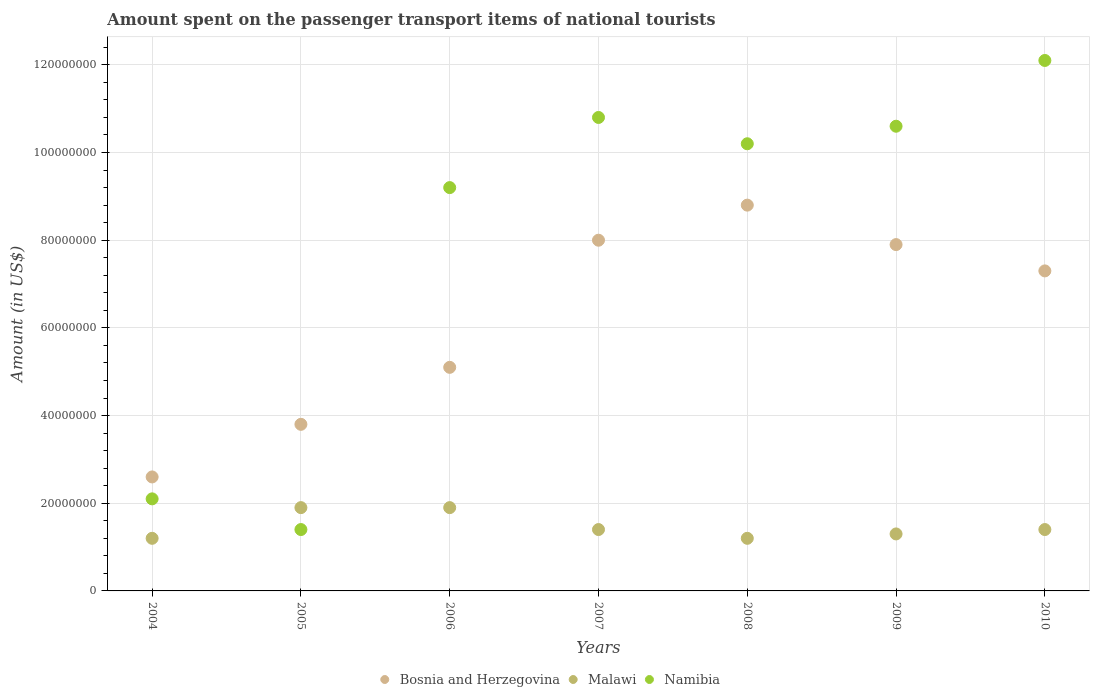How many different coloured dotlines are there?
Offer a very short reply. 3. What is the amount spent on the passenger transport items of national tourists in Bosnia and Herzegovina in 2006?
Give a very brief answer. 5.10e+07. Across all years, what is the maximum amount spent on the passenger transport items of national tourists in Namibia?
Give a very brief answer. 1.21e+08. Across all years, what is the minimum amount spent on the passenger transport items of national tourists in Namibia?
Your answer should be very brief. 1.40e+07. In which year was the amount spent on the passenger transport items of national tourists in Bosnia and Herzegovina maximum?
Give a very brief answer. 2008. In which year was the amount spent on the passenger transport items of national tourists in Bosnia and Herzegovina minimum?
Provide a succinct answer. 2004. What is the total amount spent on the passenger transport items of national tourists in Namibia in the graph?
Give a very brief answer. 5.64e+08. What is the difference between the amount spent on the passenger transport items of national tourists in Malawi in 2008 and that in 2009?
Your answer should be very brief. -1.00e+06. What is the difference between the amount spent on the passenger transport items of national tourists in Malawi in 2004 and the amount spent on the passenger transport items of national tourists in Bosnia and Herzegovina in 2007?
Keep it short and to the point. -6.80e+07. What is the average amount spent on the passenger transport items of national tourists in Namibia per year?
Your response must be concise. 8.06e+07. In the year 2005, what is the difference between the amount spent on the passenger transport items of national tourists in Bosnia and Herzegovina and amount spent on the passenger transport items of national tourists in Malawi?
Your answer should be compact. 1.90e+07. In how many years, is the amount spent on the passenger transport items of national tourists in Malawi greater than 60000000 US$?
Your answer should be very brief. 0. What is the ratio of the amount spent on the passenger transport items of national tourists in Bosnia and Herzegovina in 2004 to that in 2005?
Provide a short and direct response. 0.68. What is the difference between the highest and the second highest amount spent on the passenger transport items of national tourists in Malawi?
Ensure brevity in your answer.  0. What is the difference between the highest and the lowest amount spent on the passenger transport items of national tourists in Bosnia and Herzegovina?
Keep it short and to the point. 6.20e+07. In how many years, is the amount spent on the passenger transport items of national tourists in Namibia greater than the average amount spent on the passenger transport items of national tourists in Namibia taken over all years?
Offer a very short reply. 5. Does the amount spent on the passenger transport items of national tourists in Malawi monotonically increase over the years?
Offer a very short reply. No. Is the amount spent on the passenger transport items of national tourists in Namibia strictly greater than the amount spent on the passenger transport items of national tourists in Bosnia and Herzegovina over the years?
Provide a short and direct response. No. Is the amount spent on the passenger transport items of national tourists in Bosnia and Herzegovina strictly less than the amount spent on the passenger transport items of national tourists in Namibia over the years?
Keep it short and to the point. No. How many years are there in the graph?
Provide a succinct answer. 7. What is the difference between two consecutive major ticks on the Y-axis?
Offer a terse response. 2.00e+07. Are the values on the major ticks of Y-axis written in scientific E-notation?
Keep it short and to the point. No. Does the graph contain any zero values?
Offer a terse response. No. Where does the legend appear in the graph?
Your response must be concise. Bottom center. How many legend labels are there?
Your answer should be compact. 3. What is the title of the graph?
Give a very brief answer. Amount spent on the passenger transport items of national tourists. What is the Amount (in US$) in Bosnia and Herzegovina in 2004?
Your response must be concise. 2.60e+07. What is the Amount (in US$) in Namibia in 2004?
Make the answer very short. 2.10e+07. What is the Amount (in US$) in Bosnia and Herzegovina in 2005?
Keep it short and to the point. 3.80e+07. What is the Amount (in US$) in Malawi in 2005?
Your answer should be compact. 1.90e+07. What is the Amount (in US$) in Namibia in 2005?
Your answer should be compact. 1.40e+07. What is the Amount (in US$) in Bosnia and Herzegovina in 2006?
Ensure brevity in your answer.  5.10e+07. What is the Amount (in US$) in Malawi in 2006?
Ensure brevity in your answer.  1.90e+07. What is the Amount (in US$) of Namibia in 2006?
Provide a succinct answer. 9.20e+07. What is the Amount (in US$) of Bosnia and Herzegovina in 2007?
Ensure brevity in your answer.  8.00e+07. What is the Amount (in US$) of Malawi in 2007?
Make the answer very short. 1.40e+07. What is the Amount (in US$) in Namibia in 2007?
Provide a short and direct response. 1.08e+08. What is the Amount (in US$) in Bosnia and Herzegovina in 2008?
Ensure brevity in your answer.  8.80e+07. What is the Amount (in US$) of Namibia in 2008?
Your answer should be very brief. 1.02e+08. What is the Amount (in US$) of Bosnia and Herzegovina in 2009?
Give a very brief answer. 7.90e+07. What is the Amount (in US$) in Malawi in 2009?
Ensure brevity in your answer.  1.30e+07. What is the Amount (in US$) in Namibia in 2009?
Ensure brevity in your answer.  1.06e+08. What is the Amount (in US$) of Bosnia and Herzegovina in 2010?
Provide a short and direct response. 7.30e+07. What is the Amount (in US$) of Malawi in 2010?
Keep it short and to the point. 1.40e+07. What is the Amount (in US$) in Namibia in 2010?
Your answer should be very brief. 1.21e+08. Across all years, what is the maximum Amount (in US$) in Bosnia and Herzegovina?
Keep it short and to the point. 8.80e+07. Across all years, what is the maximum Amount (in US$) of Malawi?
Keep it short and to the point. 1.90e+07. Across all years, what is the maximum Amount (in US$) in Namibia?
Give a very brief answer. 1.21e+08. Across all years, what is the minimum Amount (in US$) of Bosnia and Herzegovina?
Your response must be concise. 2.60e+07. Across all years, what is the minimum Amount (in US$) in Namibia?
Ensure brevity in your answer.  1.40e+07. What is the total Amount (in US$) of Bosnia and Herzegovina in the graph?
Your answer should be compact. 4.35e+08. What is the total Amount (in US$) in Malawi in the graph?
Give a very brief answer. 1.03e+08. What is the total Amount (in US$) in Namibia in the graph?
Make the answer very short. 5.64e+08. What is the difference between the Amount (in US$) in Bosnia and Herzegovina in 2004 and that in 2005?
Give a very brief answer. -1.20e+07. What is the difference between the Amount (in US$) in Malawi in 2004 and that in 2005?
Keep it short and to the point. -7.00e+06. What is the difference between the Amount (in US$) in Bosnia and Herzegovina in 2004 and that in 2006?
Give a very brief answer. -2.50e+07. What is the difference between the Amount (in US$) of Malawi in 2004 and that in 2006?
Provide a short and direct response. -7.00e+06. What is the difference between the Amount (in US$) of Namibia in 2004 and that in 2006?
Your answer should be very brief. -7.10e+07. What is the difference between the Amount (in US$) in Bosnia and Herzegovina in 2004 and that in 2007?
Provide a succinct answer. -5.40e+07. What is the difference between the Amount (in US$) of Malawi in 2004 and that in 2007?
Make the answer very short. -2.00e+06. What is the difference between the Amount (in US$) in Namibia in 2004 and that in 2007?
Offer a very short reply. -8.70e+07. What is the difference between the Amount (in US$) in Bosnia and Herzegovina in 2004 and that in 2008?
Offer a terse response. -6.20e+07. What is the difference between the Amount (in US$) in Malawi in 2004 and that in 2008?
Offer a very short reply. 0. What is the difference between the Amount (in US$) of Namibia in 2004 and that in 2008?
Provide a short and direct response. -8.10e+07. What is the difference between the Amount (in US$) of Bosnia and Herzegovina in 2004 and that in 2009?
Make the answer very short. -5.30e+07. What is the difference between the Amount (in US$) in Malawi in 2004 and that in 2009?
Offer a terse response. -1.00e+06. What is the difference between the Amount (in US$) in Namibia in 2004 and that in 2009?
Ensure brevity in your answer.  -8.50e+07. What is the difference between the Amount (in US$) in Bosnia and Herzegovina in 2004 and that in 2010?
Your answer should be compact. -4.70e+07. What is the difference between the Amount (in US$) of Namibia in 2004 and that in 2010?
Offer a terse response. -1.00e+08. What is the difference between the Amount (in US$) in Bosnia and Herzegovina in 2005 and that in 2006?
Provide a succinct answer. -1.30e+07. What is the difference between the Amount (in US$) in Malawi in 2005 and that in 2006?
Make the answer very short. 0. What is the difference between the Amount (in US$) of Namibia in 2005 and that in 2006?
Offer a very short reply. -7.80e+07. What is the difference between the Amount (in US$) in Bosnia and Herzegovina in 2005 and that in 2007?
Keep it short and to the point. -4.20e+07. What is the difference between the Amount (in US$) of Malawi in 2005 and that in 2007?
Give a very brief answer. 5.00e+06. What is the difference between the Amount (in US$) in Namibia in 2005 and that in 2007?
Keep it short and to the point. -9.40e+07. What is the difference between the Amount (in US$) of Bosnia and Herzegovina in 2005 and that in 2008?
Your answer should be compact. -5.00e+07. What is the difference between the Amount (in US$) in Namibia in 2005 and that in 2008?
Your answer should be very brief. -8.80e+07. What is the difference between the Amount (in US$) of Bosnia and Herzegovina in 2005 and that in 2009?
Your answer should be very brief. -4.10e+07. What is the difference between the Amount (in US$) in Malawi in 2005 and that in 2009?
Provide a short and direct response. 6.00e+06. What is the difference between the Amount (in US$) in Namibia in 2005 and that in 2009?
Give a very brief answer. -9.20e+07. What is the difference between the Amount (in US$) of Bosnia and Herzegovina in 2005 and that in 2010?
Provide a short and direct response. -3.50e+07. What is the difference between the Amount (in US$) of Malawi in 2005 and that in 2010?
Offer a terse response. 5.00e+06. What is the difference between the Amount (in US$) of Namibia in 2005 and that in 2010?
Your response must be concise. -1.07e+08. What is the difference between the Amount (in US$) of Bosnia and Herzegovina in 2006 and that in 2007?
Give a very brief answer. -2.90e+07. What is the difference between the Amount (in US$) of Malawi in 2006 and that in 2007?
Offer a terse response. 5.00e+06. What is the difference between the Amount (in US$) of Namibia in 2006 and that in 2007?
Provide a short and direct response. -1.60e+07. What is the difference between the Amount (in US$) of Bosnia and Herzegovina in 2006 and that in 2008?
Ensure brevity in your answer.  -3.70e+07. What is the difference between the Amount (in US$) of Malawi in 2006 and that in 2008?
Give a very brief answer. 7.00e+06. What is the difference between the Amount (in US$) in Namibia in 2006 and that in 2008?
Provide a short and direct response. -1.00e+07. What is the difference between the Amount (in US$) in Bosnia and Herzegovina in 2006 and that in 2009?
Your answer should be very brief. -2.80e+07. What is the difference between the Amount (in US$) of Malawi in 2006 and that in 2009?
Your answer should be very brief. 6.00e+06. What is the difference between the Amount (in US$) in Namibia in 2006 and that in 2009?
Provide a short and direct response. -1.40e+07. What is the difference between the Amount (in US$) in Bosnia and Herzegovina in 2006 and that in 2010?
Offer a very short reply. -2.20e+07. What is the difference between the Amount (in US$) of Namibia in 2006 and that in 2010?
Ensure brevity in your answer.  -2.90e+07. What is the difference between the Amount (in US$) of Bosnia and Herzegovina in 2007 and that in 2008?
Give a very brief answer. -8.00e+06. What is the difference between the Amount (in US$) of Namibia in 2007 and that in 2008?
Provide a succinct answer. 6.00e+06. What is the difference between the Amount (in US$) of Bosnia and Herzegovina in 2007 and that in 2009?
Offer a very short reply. 1.00e+06. What is the difference between the Amount (in US$) of Malawi in 2007 and that in 2010?
Your response must be concise. 0. What is the difference between the Amount (in US$) of Namibia in 2007 and that in 2010?
Keep it short and to the point. -1.30e+07. What is the difference between the Amount (in US$) in Bosnia and Herzegovina in 2008 and that in 2009?
Provide a short and direct response. 9.00e+06. What is the difference between the Amount (in US$) of Namibia in 2008 and that in 2009?
Keep it short and to the point. -4.00e+06. What is the difference between the Amount (in US$) in Bosnia and Herzegovina in 2008 and that in 2010?
Make the answer very short. 1.50e+07. What is the difference between the Amount (in US$) of Namibia in 2008 and that in 2010?
Offer a terse response. -1.90e+07. What is the difference between the Amount (in US$) in Malawi in 2009 and that in 2010?
Give a very brief answer. -1.00e+06. What is the difference between the Amount (in US$) of Namibia in 2009 and that in 2010?
Provide a short and direct response. -1.50e+07. What is the difference between the Amount (in US$) of Bosnia and Herzegovina in 2004 and the Amount (in US$) of Namibia in 2005?
Your answer should be compact. 1.20e+07. What is the difference between the Amount (in US$) in Malawi in 2004 and the Amount (in US$) in Namibia in 2005?
Ensure brevity in your answer.  -2.00e+06. What is the difference between the Amount (in US$) in Bosnia and Herzegovina in 2004 and the Amount (in US$) in Malawi in 2006?
Keep it short and to the point. 7.00e+06. What is the difference between the Amount (in US$) in Bosnia and Herzegovina in 2004 and the Amount (in US$) in Namibia in 2006?
Ensure brevity in your answer.  -6.60e+07. What is the difference between the Amount (in US$) of Malawi in 2004 and the Amount (in US$) of Namibia in 2006?
Provide a succinct answer. -8.00e+07. What is the difference between the Amount (in US$) in Bosnia and Herzegovina in 2004 and the Amount (in US$) in Malawi in 2007?
Provide a short and direct response. 1.20e+07. What is the difference between the Amount (in US$) in Bosnia and Herzegovina in 2004 and the Amount (in US$) in Namibia in 2007?
Offer a terse response. -8.20e+07. What is the difference between the Amount (in US$) of Malawi in 2004 and the Amount (in US$) of Namibia in 2007?
Offer a terse response. -9.60e+07. What is the difference between the Amount (in US$) in Bosnia and Herzegovina in 2004 and the Amount (in US$) in Malawi in 2008?
Your answer should be compact. 1.40e+07. What is the difference between the Amount (in US$) of Bosnia and Herzegovina in 2004 and the Amount (in US$) of Namibia in 2008?
Provide a short and direct response. -7.60e+07. What is the difference between the Amount (in US$) of Malawi in 2004 and the Amount (in US$) of Namibia in 2008?
Offer a terse response. -9.00e+07. What is the difference between the Amount (in US$) in Bosnia and Herzegovina in 2004 and the Amount (in US$) in Malawi in 2009?
Ensure brevity in your answer.  1.30e+07. What is the difference between the Amount (in US$) in Bosnia and Herzegovina in 2004 and the Amount (in US$) in Namibia in 2009?
Your answer should be very brief. -8.00e+07. What is the difference between the Amount (in US$) in Malawi in 2004 and the Amount (in US$) in Namibia in 2009?
Make the answer very short. -9.40e+07. What is the difference between the Amount (in US$) in Bosnia and Herzegovina in 2004 and the Amount (in US$) in Namibia in 2010?
Provide a succinct answer. -9.50e+07. What is the difference between the Amount (in US$) in Malawi in 2004 and the Amount (in US$) in Namibia in 2010?
Provide a succinct answer. -1.09e+08. What is the difference between the Amount (in US$) in Bosnia and Herzegovina in 2005 and the Amount (in US$) in Malawi in 2006?
Provide a short and direct response. 1.90e+07. What is the difference between the Amount (in US$) in Bosnia and Herzegovina in 2005 and the Amount (in US$) in Namibia in 2006?
Make the answer very short. -5.40e+07. What is the difference between the Amount (in US$) in Malawi in 2005 and the Amount (in US$) in Namibia in 2006?
Keep it short and to the point. -7.30e+07. What is the difference between the Amount (in US$) in Bosnia and Herzegovina in 2005 and the Amount (in US$) in Malawi in 2007?
Keep it short and to the point. 2.40e+07. What is the difference between the Amount (in US$) in Bosnia and Herzegovina in 2005 and the Amount (in US$) in Namibia in 2007?
Provide a short and direct response. -7.00e+07. What is the difference between the Amount (in US$) of Malawi in 2005 and the Amount (in US$) of Namibia in 2007?
Give a very brief answer. -8.90e+07. What is the difference between the Amount (in US$) of Bosnia and Herzegovina in 2005 and the Amount (in US$) of Malawi in 2008?
Provide a short and direct response. 2.60e+07. What is the difference between the Amount (in US$) of Bosnia and Herzegovina in 2005 and the Amount (in US$) of Namibia in 2008?
Your answer should be compact. -6.40e+07. What is the difference between the Amount (in US$) of Malawi in 2005 and the Amount (in US$) of Namibia in 2008?
Provide a succinct answer. -8.30e+07. What is the difference between the Amount (in US$) of Bosnia and Herzegovina in 2005 and the Amount (in US$) of Malawi in 2009?
Your answer should be compact. 2.50e+07. What is the difference between the Amount (in US$) in Bosnia and Herzegovina in 2005 and the Amount (in US$) in Namibia in 2009?
Offer a terse response. -6.80e+07. What is the difference between the Amount (in US$) of Malawi in 2005 and the Amount (in US$) of Namibia in 2009?
Make the answer very short. -8.70e+07. What is the difference between the Amount (in US$) of Bosnia and Herzegovina in 2005 and the Amount (in US$) of Malawi in 2010?
Keep it short and to the point. 2.40e+07. What is the difference between the Amount (in US$) of Bosnia and Herzegovina in 2005 and the Amount (in US$) of Namibia in 2010?
Provide a succinct answer. -8.30e+07. What is the difference between the Amount (in US$) of Malawi in 2005 and the Amount (in US$) of Namibia in 2010?
Ensure brevity in your answer.  -1.02e+08. What is the difference between the Amount (in US$) of Bosnia and Herzegovina in 2006 and the Amount (in US$) of Malawi in 2007?
Your answer should be compact. 3.70e+07. What is the difference between the Amount (in US$) of Bosnia and Herzegovina in 2006 and the Amount (in US$) of Namibia in 2007?
Your response must be concise. -5.70e+07. What is the difference between the Amount (in US$) of Malawi in 2006 and the Amount (in US$) of Namibia in 2007?
Make the answer very short. -8.90e+07. What is the difference between the Amount (in US$) in Bosnia and Herzegovina in 2006 and the Amount (in US$) in Malawi in 2008?
Offer a terse response. 3.90e+07. What is the difference between the Amount (in US$) in Bosnia and Herzegovina in 2006 and the Amount (in US$) in Namibia in 2008?
Offer a terse response. -5.10e+07. What is the difference between the Amount (in US$) of Malawi in 2006 and the Amount (in US$) of Namibia in 2008?
Provide a short and direct response. -8.30e+07. What is the difference between the Amount (in US$) in Bosnia and Herzegovina in 2006 and the Amount (in US$) in Malawi in 2009?
Offer a terse response. 3.80e+07. What is the difference between the Amount (in US$) of Bosnia and Herzegovina in 2006 and the Amount (in US$) of Namibia in 2009?
Offer a terse response. -5.50e+07. What is the difference between the Amount (in US$) of Malawi in 2006 and the Amount (in US$) of Namibia in 2009?
Offer a terse response. -8.70e+07. What is the difference between the Amount (in US$) of Bosnia and Herzegovina in 2006 and the Amount (in US$) of Malawi in 2010?
Your answer should be compact. 3.70e+07. What is the difference between the Amount (in US$) in Bosnia and Herzegovina in 2006 and the Amount (in US$) in Namibia in 2010?
Your answer should be compact. -7.00e+07. What is the difference between the Amount (in US$) in Malawi in 2006 and the Amount (in US$) in Namibia in 2010?
Make the answer very short. -1.02e+08. What is the difference between the Amount (in US$) of Bosnia and Herzegovina in 2007 and the Amount (in US$) of Malawi in 2008?
Offer a terse response. 6.80e+07. What is the difference between the Amount (in US$) of Bosnia and Herzegovina in 2007 and the Amount (in US$) of Namibia in 2008?
Your answer should be very brief. -2.20e+07. What is the difference between the Amount (in US$) in Malawi in 2007 and the Amount (in US$) in Namibia in 2008?
Keep it short and to the point. -8.80e+07. What is the difference between the Amount (in US$) of Bosnia and Herzegovina in 2007 and the Amount (in US$) of Malawi in 2009?
Give a very brief answer. 6.70e+07. What is the difference between the Amount (in US$) in Bosnia and Herzegovina in 2007 and the Amount (in US$) in Namibia in 2009?
Offer a very short reply. -2.60e+07. What is the difference between the Amount (in US$) in Malawi in 2007 and the Amount (in US$) in Namibia in 2009?
Provide a succinct answer. -9.20e+07. What is the difference between the Amount (in US$) in Bosnia and Herzegovina in 2007 and the Amount (in US$) in Malawi in 2010?
Keep it short and to the point. 6.60e+07. What is the difference between the Amount (in US$) of Bosnia and Herzegovina in 2007 and the Amount (in US$) of Namibia in 2010?
Offer a terse response. -4.10e+07. What is the difference between the Amount (in US$) in Malawi in 2007 and the Amount (in US$) in Namibia in 2010?
Ensure brevity in your answer.  -1.07e+08. What is the difference between the Amount (in US$) in Bosnia and Herzegovina in 2008 and the Amount (in US$) in Malawi in 2009?
Your response must be concise. 7.50e+07. What is the difference between the Amount (in US$) of Bosnia and Herzegovina in 2008 and the Amount (in US$) of Namibia in 2009?
Offer a terse response. -1.80e+07. What is the difference between the Amount (in US$) in Malawi in 2008 and the Amount (in US$) in Namibia in 2009?
Your answer should be compact. -9.40e+07. What is the difference between the Amount (in US$) of Bosnia and Herzegovina in 2008 and the Amount (in US$) of Malawi in 2010?
Offer a terse response. 7.40e+07. What is the difference between the Amount (in US$) of Bosnia and Herzegovina in 2008 and the Amount (in US$) of Namibia in 2010?
Your answer should be very brief. -3.30e+07. What is the difference between the Amount (in US$) of Malawi in 2008 and the Amount (in US$) of Namibia in 2010?
Provide a succinct answer. -1.09e+08. What is the difference between the Amount (in US$) of Bosnia and Herzegovina in 2009 and the Amount (in US$) of Malawi in 2010?
Your answer should be very brief. 6.50e+07. What is the difference between the Amount (in US$) in Bosnia and Herzegovina in 2009 and the Amount (in US$) in Namibia in 2010?
Your answer should be very brief. -4.20e+07. What is the difference between the Amount (in US$) of Malawi in 2009 and the Amount (in US$) of Namibia in 2010?
Give a very brief answer. -1.08e+08. What is the average Amount (in US$) in Bosnia and Herzegovina per year?
Provide a short and direct response. 6.21e+07. What is the average Amount (in US$) of Malawi per year?
Keep it short and to the point. 1.47e+07. What is the average Amount (in US$) in Namibia per year?
Make the answer very short. 8.06e+07. In the year 2004, what is the difference between the Amount (in US$) in Bosnia and Herzegovina and Amount (in US$) in Malawi?
Make the answer very short. 1.40e+07. In the year 2004, what is the difference between the Amount (in US$) in Bosnia and Herzegovina and Amount (in US$) in Namibia?
Keep it short and to the point. 5.00e+06. In the year 2004, what is the difference between the Amount (in US$) in Malawi and Amount (in US$) in Namibia?
Give a very brief answer. -9.00e+06. In the year 2005, what is the difference between the Amount (in US$) in Bosnia and Herzegovina and Amount (in US$) in Malawi?
Your response must be concise. 1.90e+07. In the year 2005, what is the difference between the Amount (in US$) of Bosnia and Herzegovina and Amount (in US$) of Namibia?
Keep it short and to the point. 2.40e+07. In the year 2005, what is the difference between the Amount (in US$) in Malawi and Amount (in US$) in Namibia?
Provide a succinct answer. 5.00e+06. In the year 2006, what is the difference between the Amount (in US$) of Bosnia and Herzegovina and Amount (in US$) of Malawi?
Offer a terse response. 3.20e+07. In the year 2006, what is the difference between the Amount (in US$) in Bosnia and Herzegovina and Amount (in US$) in Namibia?
Provide a short and direct response. -4.10e+07. In the year 2006, what is the difference between the Amount (in US$) in Malawi and Amount (in US$) in Namibia?
Ensure brevity in your answer.  -7.30e+07. In the year 2007, what is the difference between the Amount (in US$) in Bosnia and Herzegovina and Amount (in US$) in Malawi?
Your answer should be very brief. 6.60e+07. In the year 2007, what is the difference between the Amount (in US$) in Bosnia and Herzegovina and Amount (in US$) in Namibia?
Offer a very short reply. -2.80e+07. In the year 2007, what is the difference between the Amount (in US$) in Malawi and Amount (in US$) in Namibia?
Your answer should be compact. -9.40e+07. In the year 2008, what is the difference between the Amount (in US$) of Bosnia and Herzegovina and Amount (in US$) of Malawi?
Provide a short and direct response. 7.60e+07. In the year 2008, what is the difference between the Amount (in US$) of Bosnia and Herzegovina and Amount (in US$) of Namibia?
Your answer should be very brief. -1.40e+07. In the year 2008, what is the difference between the Amount (in US$) in Malawi and Amount (in US$) in Namibia?
Give a very brief answer. -9.00e+07. In the year 2009, what is the difference between the Amount (in US$) in Bosnia and Herzegovina and Amount (in US$) in Malawi?
Provide a succinct answer. 6.60e+07. In the year 2009, what is the difference between the Amount (in US$) in Bosnia and Herzegovina and Amount (in US$) in Namibia?
Provide a succinct answer. -2.70e+07. In the year 2009, what is the difference between the Amount (in US$) of Malawi and Amount (in US$) of Namibia?
Provide a succinct answer. -9.30e+07. In the year 2010, what is the difference between the Amount (in US$) of Bosnia and Herzegovina and Amount (in US$) of Malawi?
Keep it short and to the point. 5.90e+07. In the year 2010, what is the difference between the Amount (in US$) of Bosnia and Herzegovina and Amount (in US$) of Namibia?
Your answer should be compact. -4.80e+07. In the year 2010, what is the difference between the Amount (in US$) in Malawi and Amount (in US$) in Namibia?
Your answer should be compact. -1.07e+08. What is the ratio of the Amount (in US$) of Bosnia and Herzegovina in 2004 to that in 2005?
Your answer should be very brief. 0.68. What is the ratio of the Amount (in US$) in Malawi in 2004 to that in 2005?
Your answer should be very brief. 0.63. What is the ratio of the Amount (in US$) in Namibia in 2004 to that in 2005?
Offer a terse response. 1.5. What is the ratio of the Amount (in US$) in Bosnia and Herzegovina in 2004 to that in 2006?
Your answer should be compact. 0.51. What is the ratio of the Amount (in US$) of Malawi in 2004 to that in 2006?
Your response must be concise. 0.63. What is the ratio of the Amount (in US$) in Namibia in 2004 to that in 2006?
Offer a very short reply. 0.23. What is the ratio of the Amount (in US$) of Bosnia and Herzegovina in 2004 to that in 2007?
Make the answer very short. 0.33. What is the ratio of the Amount (in US$) in Malawi in 2004 to that in 2007?
Provide a succinct answer. 0.86. What is the ratio of the Amount (in US$) of Namibia in 2004 to that in 2007?
Give a very brief answer. 0.19. What is the ratio of the Amount (in US$) of Bosnia and Herzegovina in 2004 to that in 2008?
Provide a short and direct response. 0.3. What is the ratio of the Amount (in US$) of Malawi in 2004 to that in 2008?
Your answer should be very brief. 1. What is the ratio of the Amount (in US$) in Namibia in 2004 to that in 2008?
Make the answer very short. 0.21. What is the ratio of the Amount (in US$) in Bosnia and Herzegovina in 2004 to that in 2009?
Give a very brief answer. 0.33. What is the ratio of the Amount (in US$) of Namibia in 2004 to that in 2009?
Your answer should be compact. 0.2. What is the ratio of the Amount (in US$) of Bosnia and Herzegovina in 2004 to that in 2010?
Give a very brief answer. 0.36. What is the ratio of the Amount (in US$) of Malawi in 2004 to that in 2010?
Give a very brief answer. 0.86. What is the ratio of the Amount (in US$) of Namibia in 2004 to that in 2010?
Your response must be concise. 0.17. What is the ratio of the Amount (in US$) in Bosnia and Herzegovina in 2005 to that in 2006?
Offer a very short reply. 0.75. What is the ratio of the Amount (in US$) of Namibia in 2005 to that in 2006?
Your response must be concise. 0.15. What is the ratio of the Amount (in US$) of Bosnia and Herzegovina in 2005 to that in 2007?
Offer a very short reply. 0.47. What is the ratio of the Amount (in US$) in Malawi in 2005 to that in 2007?
Your answer should be very brief. 1.36. What is the ratio of the Amount (in US$) in Namibia in 2005 to that in 2007?
Offer a very short reply. 0.13. What is the ratio of the Amount (in US$) of Bosnia and Herzegovina in 2005 to that in 2008?
Offer a terse response. 0.43. What is the ratio of the Amount (in US$) of Malawi in 2005 to that in 2008?
Offer a very short reply. 1.58. What is the ratio of the Amount (in US$) in Namibia in 2005 to that in 2008?
Your answer should be very brief. 0.14. What is the ratio of the Amount (in US$) of Bosnia and Herzegovina in 2005 to that in 2009?
Your response must be concise. 0.48. What is the ratio of the Amount (in US$) of Malawi in 2005 to that in 2009?
Provide a short and direct response. 1.46. What is the ratio of the Amount (in US$) of Namibia in 2005 to that in 2009?
Offer a very short reply. 0.13. What is the ratio of the Amount (in US$) in Bosnia and Herzegovina in 2005 to that in 2010?
Your response must be concise. 0.52. What is the ratio of the Amount (in US$) of Malawi in 2005 to that in 2010?
Keep it short and to the point. 1.36. What is the ratio of the Amount (in US$) of Namibia in 2005 to that in 2010?
Your answer should be compact. 0.12. What is the ratio of the Amount (in US$) of Bosnia and Herzegovina in 2006 to that in 2007?
Provide a short and direct response. 0.64. What is the ratio of the Amount (in US$) of Malawi in 2006 to that in 2007?
Your answer should be compact. 1.36. What is the ratio of the Amount (in US$) of Namibia in 2006 to that in 2007?
Offer a terse response. 0.85. What is the ratio of the Amount (in US$) in Bosnia and Herzegovina in 2006 to that in 2008?
Provide a short and direct response. 0.58. What is the ratio of the Amount (in US$) in Malawi in 2006 to that in 2008?
Your response must be concise. 1.58. What is the ratio of the Amount (in US$) in Namibia in 2006 to that in 2008?
Your answer should be very brief. 0.9. What is the ratio of the Amount (in US$) of Bosnia and Herzegovina in 2006 to that in 2009?
Your answer should be compact. 0.65. What is the ratio of the Amount (in US$) of Malawi in 2006 to that in 2009?
Your answer should be very brief. 1.46. What is the ratio of the Amount (in US$) of Namibia in 2006 to that in 2009?
Offer a terse response. 0.87. What is the ratio of the Amount (in US$) of Bosnia and Herzegovina in 2006 to that in 2010?
Ensure brevity in your answer.  0.7. What is the ratio of the Amount (in US$) of Malawi in 2006 to that in 2010?
Keep it short and to the point. 1.36. What is the ratio of the Amount (in US$) in Namibia in 2006 to that in 2010?
Provide a succinct answer. 0.76. What is the ratio of the Amount (in US$) of Namibia in 2007 to that in 2008?
Give a very brief answer. 1.06. What is the ratio of the Amount (in US$) of Bosnia and Herzegovina in 2007 to that in 2009?
Offer a very short reply. 1.01. What is the ratio of the Amount (in US$) in Malawi in 2007 to that in 2009?
Provide a short and direct response. 1.08. What is the ratio of the Amount (in US$) of Namibia in 2007 to that in 2009?
Make the answer very short. 1.02. What is the ratio of the Amount (in US$) in Bosnia and Herzegovina in 2007 to that in 2010?
Provide a succinct answer. 1.1. What is the ratio of the Amount (in US$) of Malawi in 2007 to that in 2010?
Make the answer very short. 1. What is the ratio of the Amount (in US$) of Namibia in 2007 to that in 2010?
Make the answer very short. 0.89. What is the ratio of the Amount (in US$) in Bosnia and Herzegovina in 2008 to that in 2009?
Provide a short and direct response. 1.11. What is the ratio of the Amount (in US$) in Malawi in 2008 to that in 2009?
Offer a very short reply. 0.92. What is the ratio of the Amount (in US$) of Namibia in 2008 to that in 2009?
Provide a succinct answer. 0.96. What is the ratio of the Amount (in US$) of Bosnia and Herzegovina in 2008 to that in 2010?
Your response must be concise. 1.21. What is the ratio of the Amount (in US$) in Namibia in 2008 to that in 2010?
Ensure brevity in your answer.  0.84. What is the ratio of the Amount (in US$) in Bosnia and Herzegovina in 2009 to that in 2010?
Your answer should be compact. 1.08. What is the ratio of the Amount (in US$) of Namibia in 2009 to that in 2010?
Keep it short and to the point. 0.88. What is the difference between the highest and the second highest Amount (in US$) of Malawi?
Your answer should be compact. 0. What is the difference between the highest and the second highest Amount (in US$) of Namibia?
Give a very brief answer. 1.30e+07. What is the difference between the highest and the lowest Amount (in US$) in Bosnia and Herzegovina?
Make the answer very short. 6.20e+07. What is the difference between the highest and the lowest Amount (in US$) of Malawi?
Offer a very short reply. 7.00e+06. What is the difference between the highest and the lowest Amount (in US$) in Namibia?
Your answer should be very brief. 1.07e+08. 